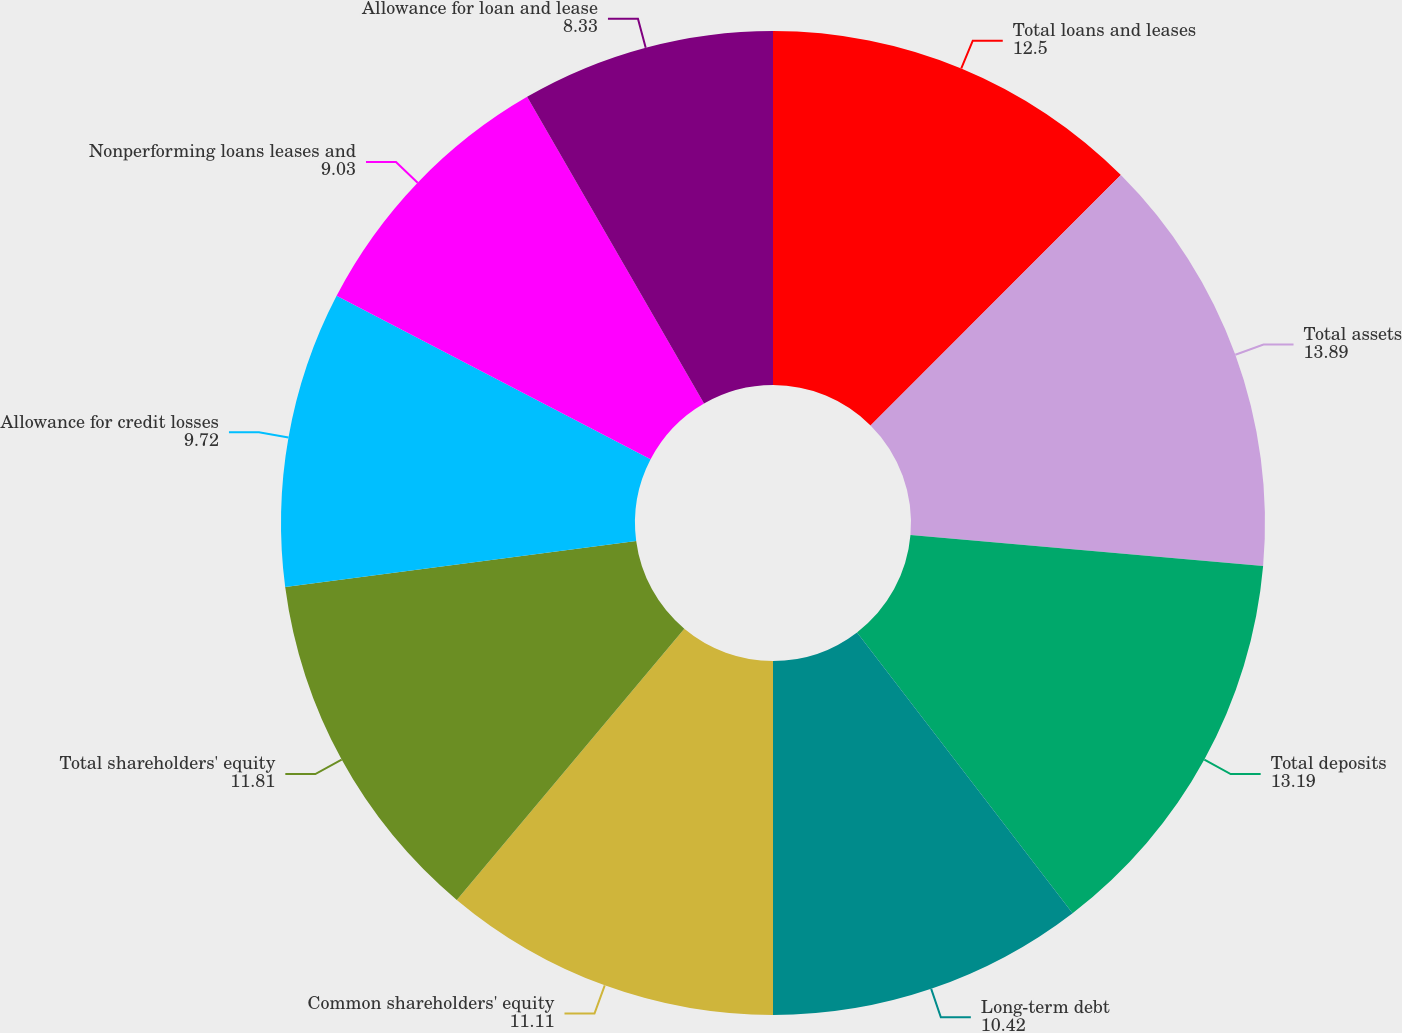<chart> <loc_0><loc_0><loc_500><loc_500><pie_chart><fcel>Total loans and leases<fcel>Total assets<fcel>Total deposits<fcel>Long-term debt<fcel>Common shareholders' equity<fcel>Total shareholders' equity<fcel>Allowance for credit losses<fcel>Nonperforming loans leases and<fcel>Allowance for loan and lease<nl><fcel>12.5%<fcel>13.89%<fcel>13.19%<fcel>10.42%<fcel>11.11%<fcel>11.81%<fcel>9.72%<fcel>9.03%<fcel>8.33%<nl></chart> 